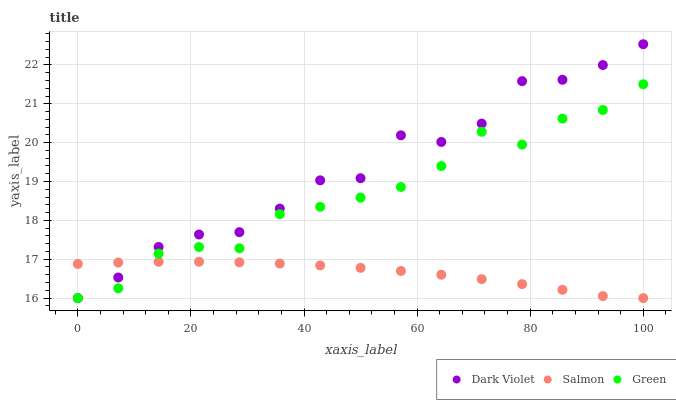Does Salmon have the minimum area under the curve?
Answer yes or no. Yes. Does Dark Violet have the maximum area under the curve?
Answer yes or no. Yes. Does Dark Violet have the minimum area under the curve?
Answer yes or no. No. Does Salmon have the maximum area under the curve?
Answer yes or no. No. Is Salmon the smoothest?
Answer yes or no. Yes. Is Dark Violet the roughest?
Answer yes or no. Yes. Is Dark Violet the smoothest?
Answer yes or no. No. Is Salmon the roughest?
Answer yes or no. No. Does Green have the lowest value?
Answer yes or no. Yes. Does Dark Violet have the highest value?
Answer yes or no. Yes. Does Salmon have the highest value?
Answer yes or no. No. Does Salmon intersect Green?
Answer yes or no. Yes. Is Salmon less than Green?
Answer yes or no. No. Is Salmon greater than Green?
Answer yes or no. No. 